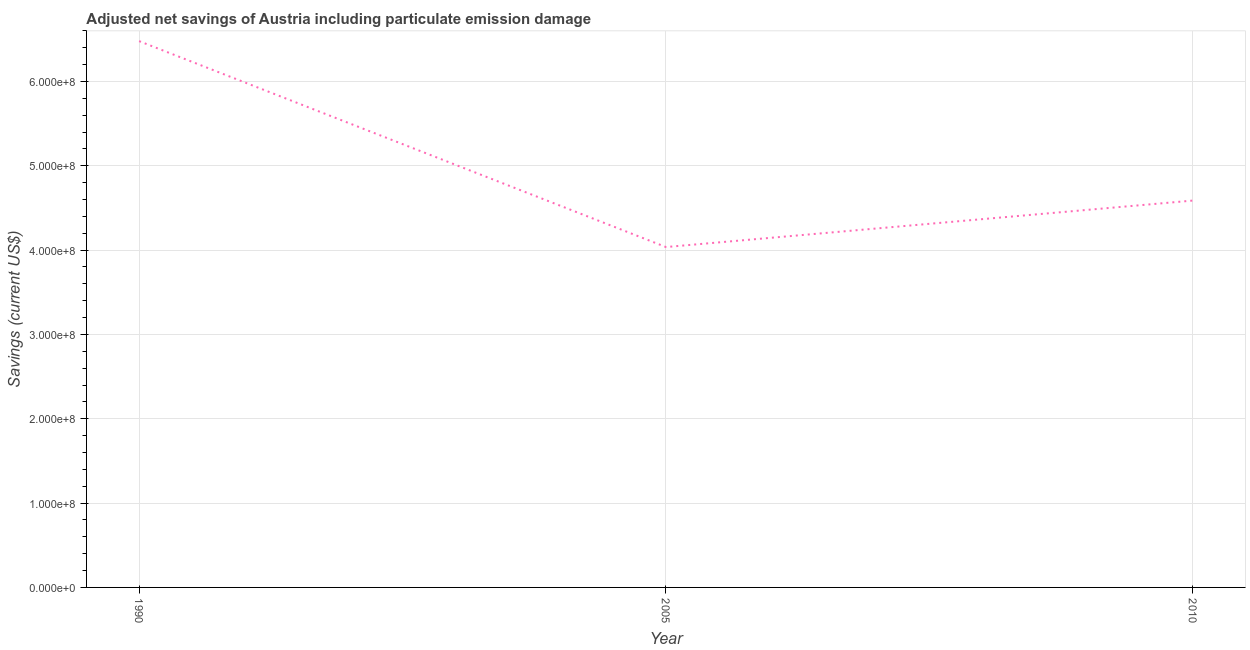What is the adjusted net savings in 2010?
Your answer should be compact. 4.59e+08. Across all years, what is the maximum adjusted net savings?
Give a very brief answer. 6.48e+08. Across all years, what is the minimum adjusted net savings?
Provide a short and direct response. 4.04e+08. In which year was the adjusted net savings maximum?
Offer a very short reply. 1990. What is the sum of the adjusted net savings?
Provide a short and direct response. 1.51e+09. What is the difference between the adjusted net savings in 2005 and 2010?
Provide a short and direct response. -5.51e+07. What is the average adjusted net savings per year?
Offer a terse response. 5.03e+08. What is the median adjusted net savings?
Provide a short and direct response. 4.59e+08. In how many years, is the adjusted net savings greater than 360000000 US$?
Keep it short and to the point. 3. Do a majority of the years between 1990 and 2005 (inclusive) have adjusted net savings greater than 300000000 US$?
Your response must be concise. Yes. What is the ratio of the adjusted net savings in 2005 to that in 2010?
Make the answer very short. 0.88. Is the difference between the adjusted net savings in 1990 and 2010 greater than the difference between any two years?
Your answer should be compact. No. What is the difference between the highest and the second highest adjusted net savings?
Your answer should be compact. 1.89e+08. What is the difference between the highest and the lowest adjusted net savings?
Offer a terse response. 2.44e+08. In how many years, is the adjusted net savings greater than the average adjusted net savings taken over all years?
Your answer should be very brief. 1. How many years are there in the graph?
Your answer should be very brief. 3. What is the difference between two consecutive major ticks on the Y-axis?
Give a very brief answer. 1.00e+08. Does the graph contain grids?
Your answer should be compact. Yes. What is the title of the graph?
Give a very brief answer. Adjusted net savings of Austria including particulate emission damage. What is the label or title of the X-axis?
Make the answer very short. Year. What is the label or title of the Y-axis?
Offer a very short reply. Savings (current US$). What is the Savings (current US$) in 1990?
Offer a terse response. 6.48e+08. What is the Savings (current US$) of 2005?
Provide a succinct answer. 4.04e+08. What is the Savings (current US$) of 2010?
Make the answer very short. 4.59e+08. What is the difference between the Savings (current US$) in 1990 and 2005?
Ensure brevity in your answer.  2.44e+08. What is the difference between the Savings (current US$) in 1990 and 2010?
Your response must be concise. 1.89e+08. What is the difference between the Savings (current US$) in 2005 and 2010?
Offer a terse response. -5.51e+07. What is the ratio of the Savings (current US$) in 1990 to that in 2005?
Your answer should be compact. 1.6. What is the ratio of the Savings (current US$) in 1990 to that in 2010?
Provide a succinct answer. 1.41. 